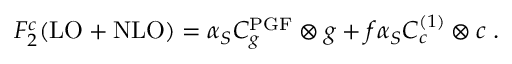<formula> <loc_0><loc_0><loc_500><loc_500>F _ { 2 } ^ { c } ( L O + N L O ) = \alpha _ { S } C _ { g } ^ { P G F } \otimes g + f \alpha _ { S } C _ { c } ^ { ( 1 ) } \otimes c \, .</formula> 